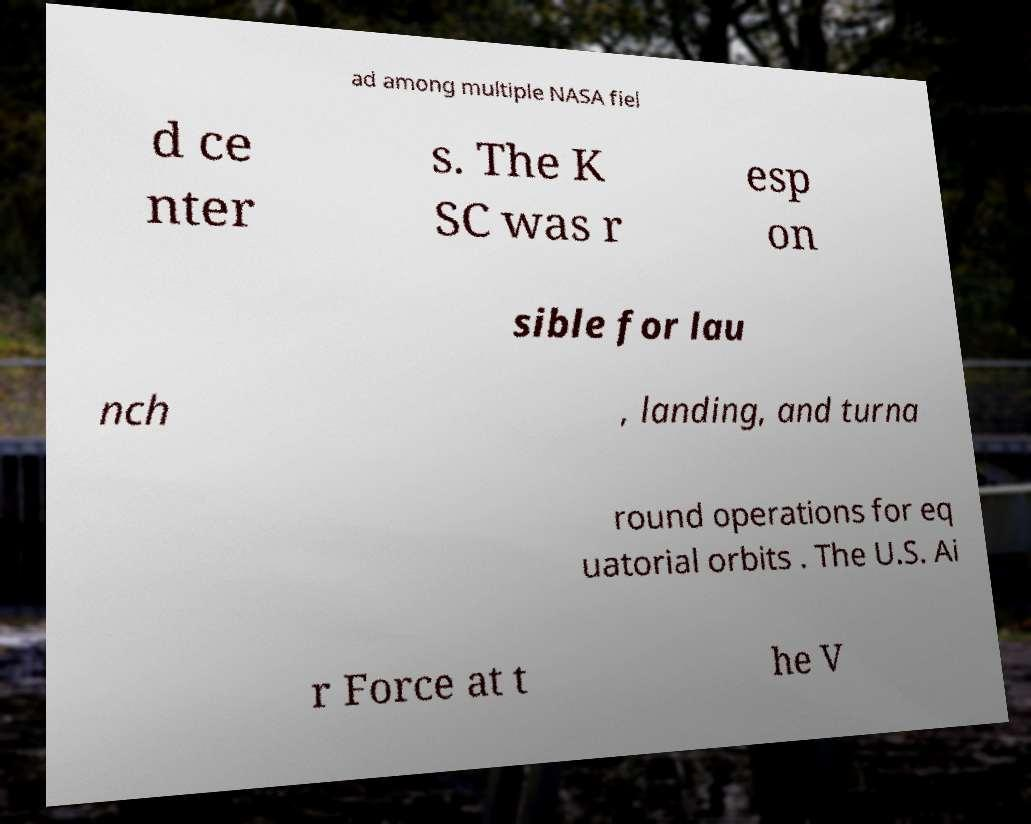Please read and relay the text visible in this image. What does it say? ad among multiple NASA fiel d ce nter s. The K SC was r esp on sible for lau nch , landing, and turna round operations for eq uatorial orbits . The U.S. Ai r Force at t he V 